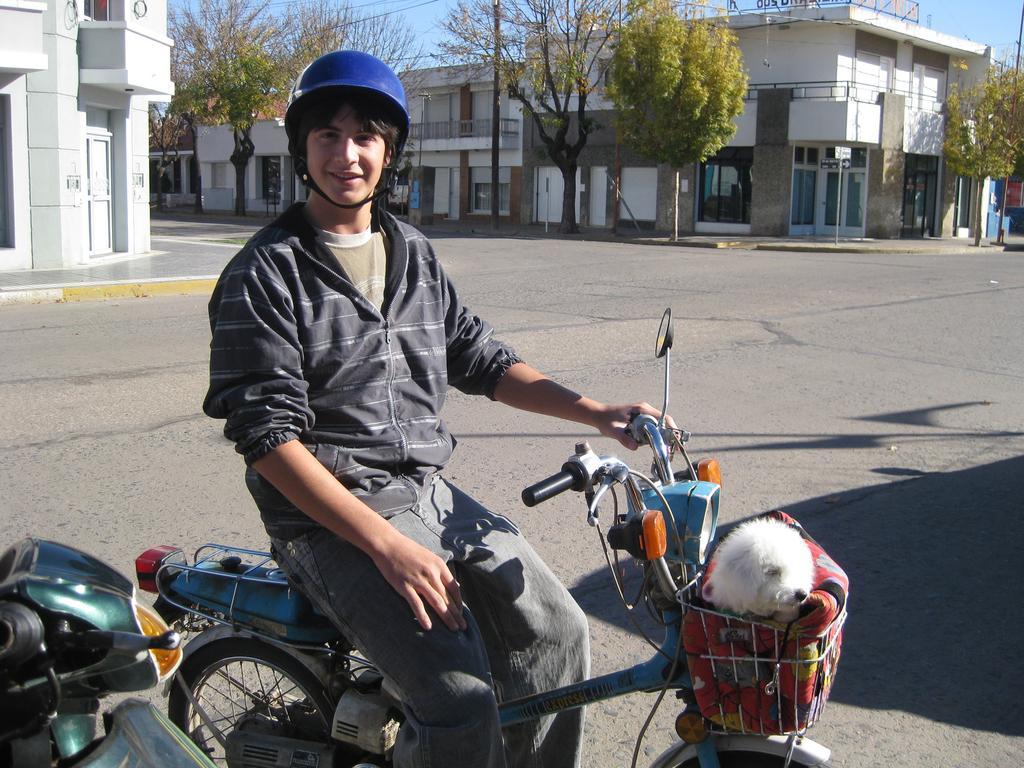Can you describe this image briefly? This image is taken outdoors. At the bottom of the image there is a road. A bike is parked on the road and a boy is sitting on the bike and there is a cat in the basket. In the background there are a few buildings and there are a few trees. At the top of the image there is a sky. 